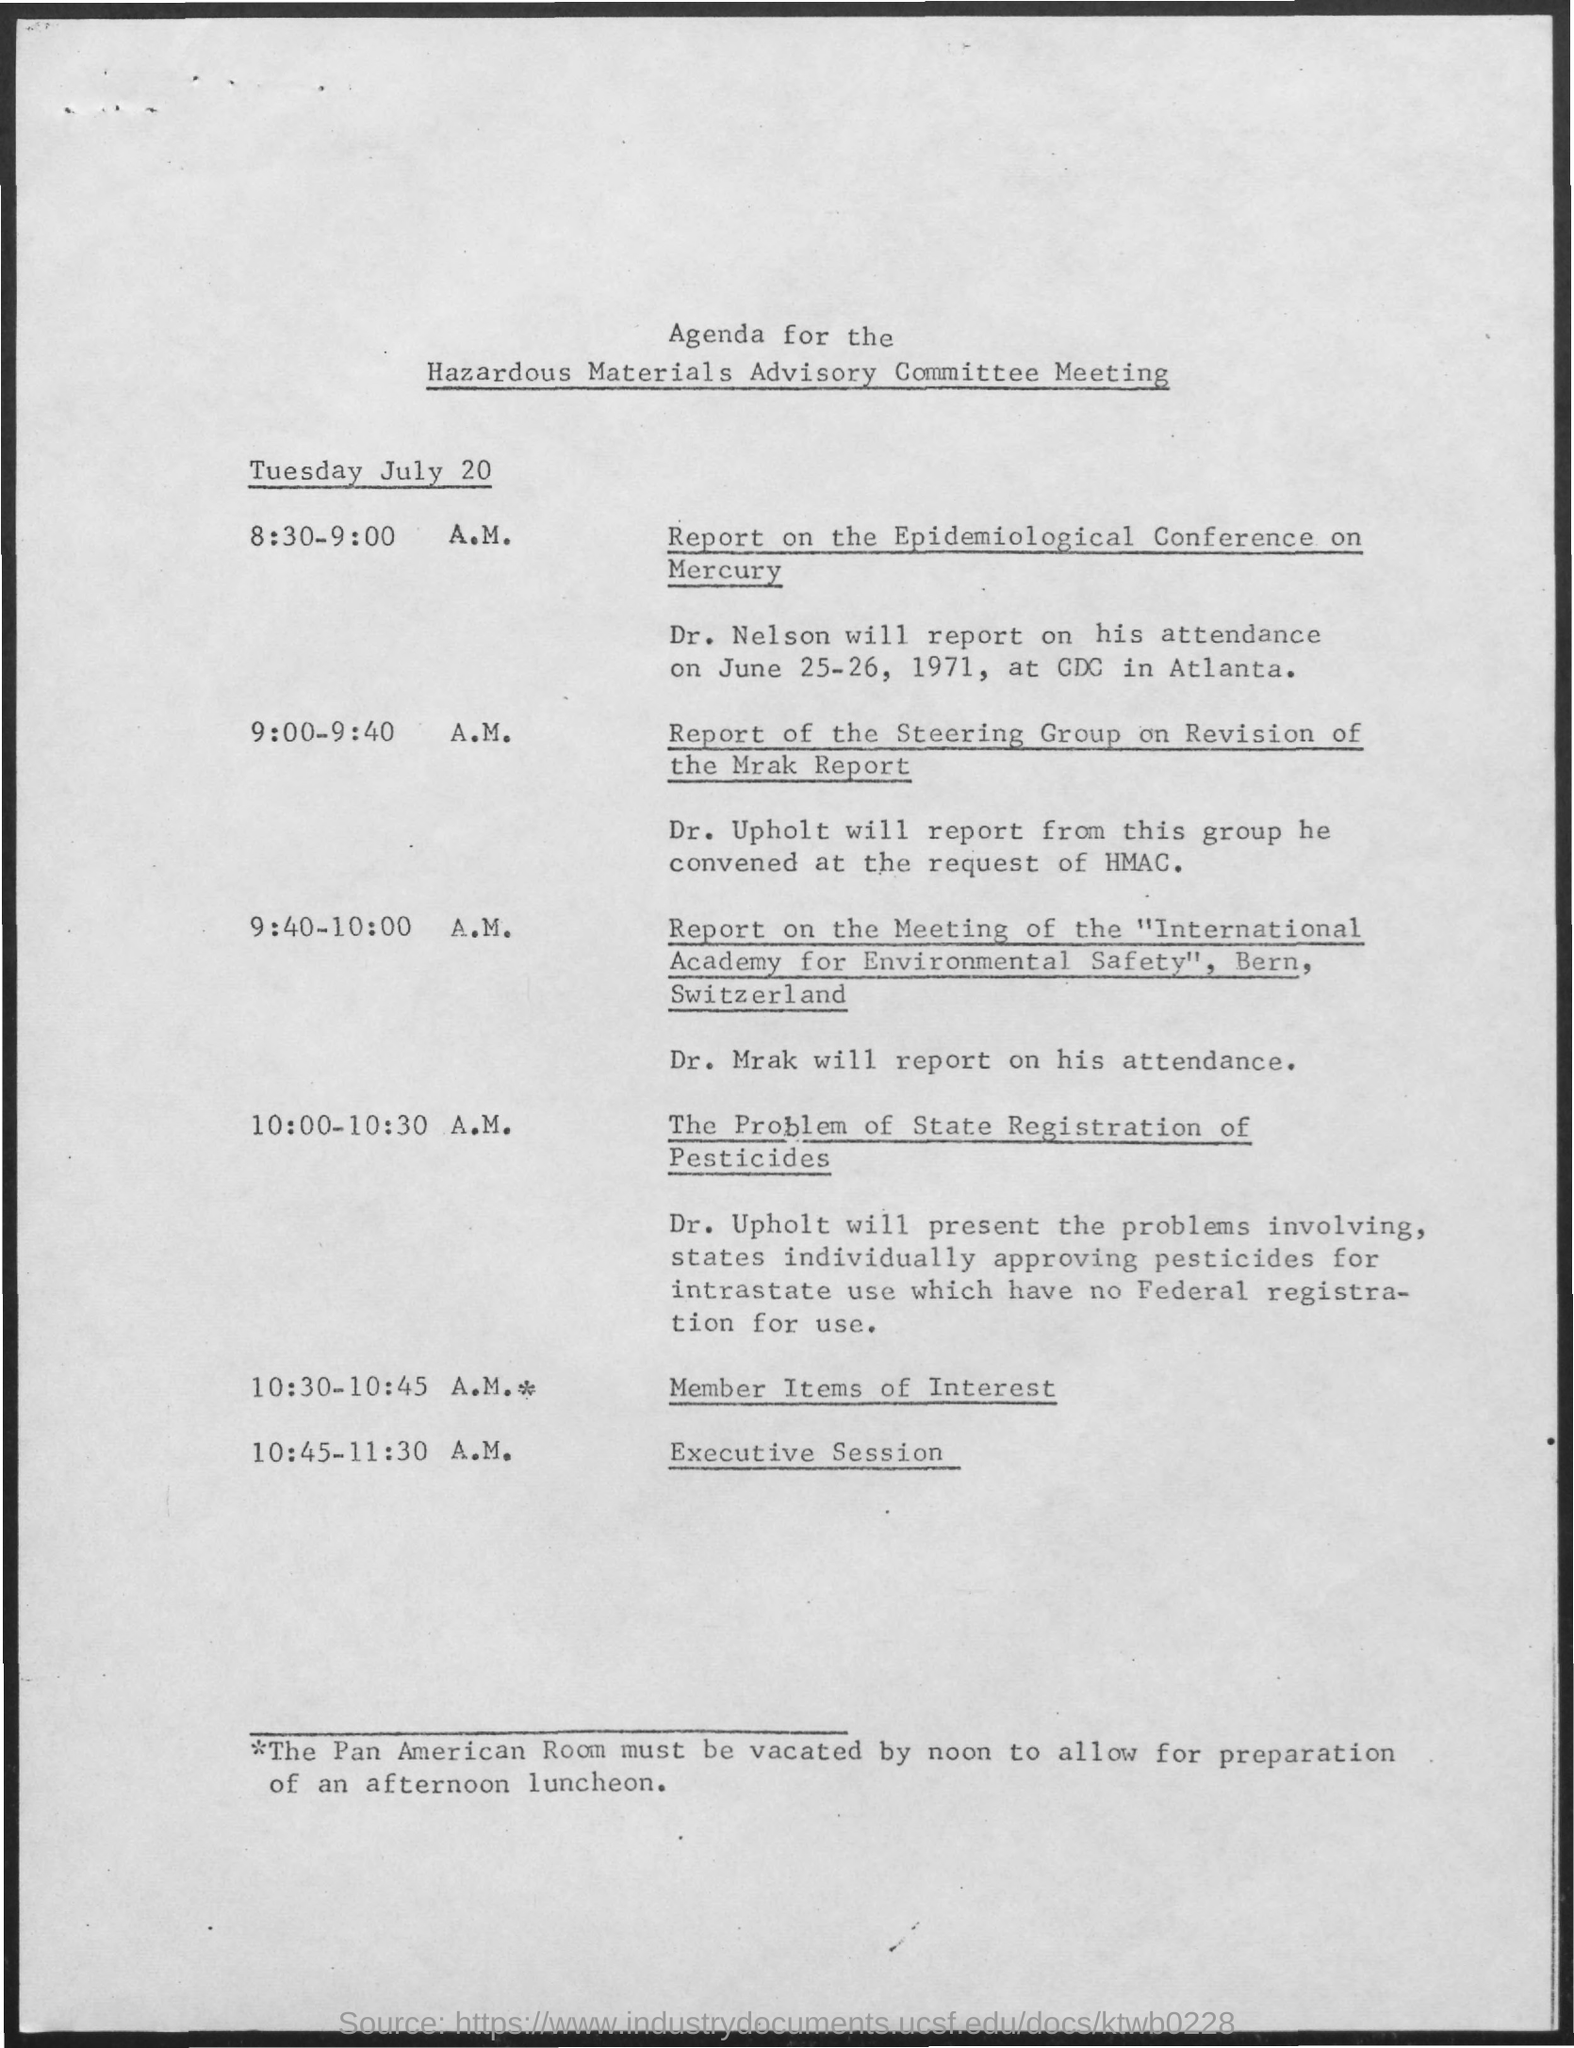What is the name of the meeting ?
Your answer should be very brief. Hazardous Materials Advisory Committee Meeting. 